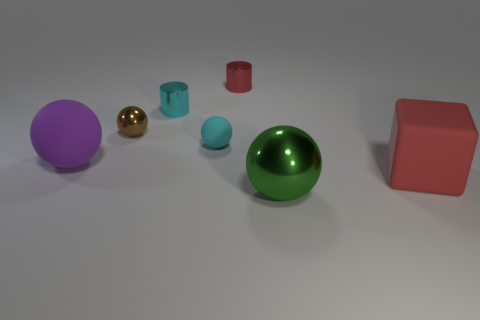What number of other objects are there of the same material as the purple object?
Ensure brevity in your answer.  2. The small cylinder behind the shiny cylinder that is in front of the red thing that is to the left of the matte block is what color?
Keep it short and to the point. Red. There is a cyan cylinder that is the same size as the red cylinder; what material is it?
Provide a short and direct response. Metal. How many things are either objects left of the brown sphere or green matte things?
Give a very brief answer. 1. Are any large green metallic balls visible?
Make the answer very short. Yes. What is the thing in front of the rubber block made of?
Keep it short and to the point. Metal. What material is the small cylinder that is the same color as the tiny rubber thing?
Keep it short and to the point. Metal. How many small objects are green metallic spheres or purple spheres?
Give a very brief answer. 0. What color is the matte cube?
Make the answer very short. Red. There is a big matte object that is left of the big metal ball; is there a tiny brown metallic sphere that is in front of it?
Provide a short and direct response. No. 